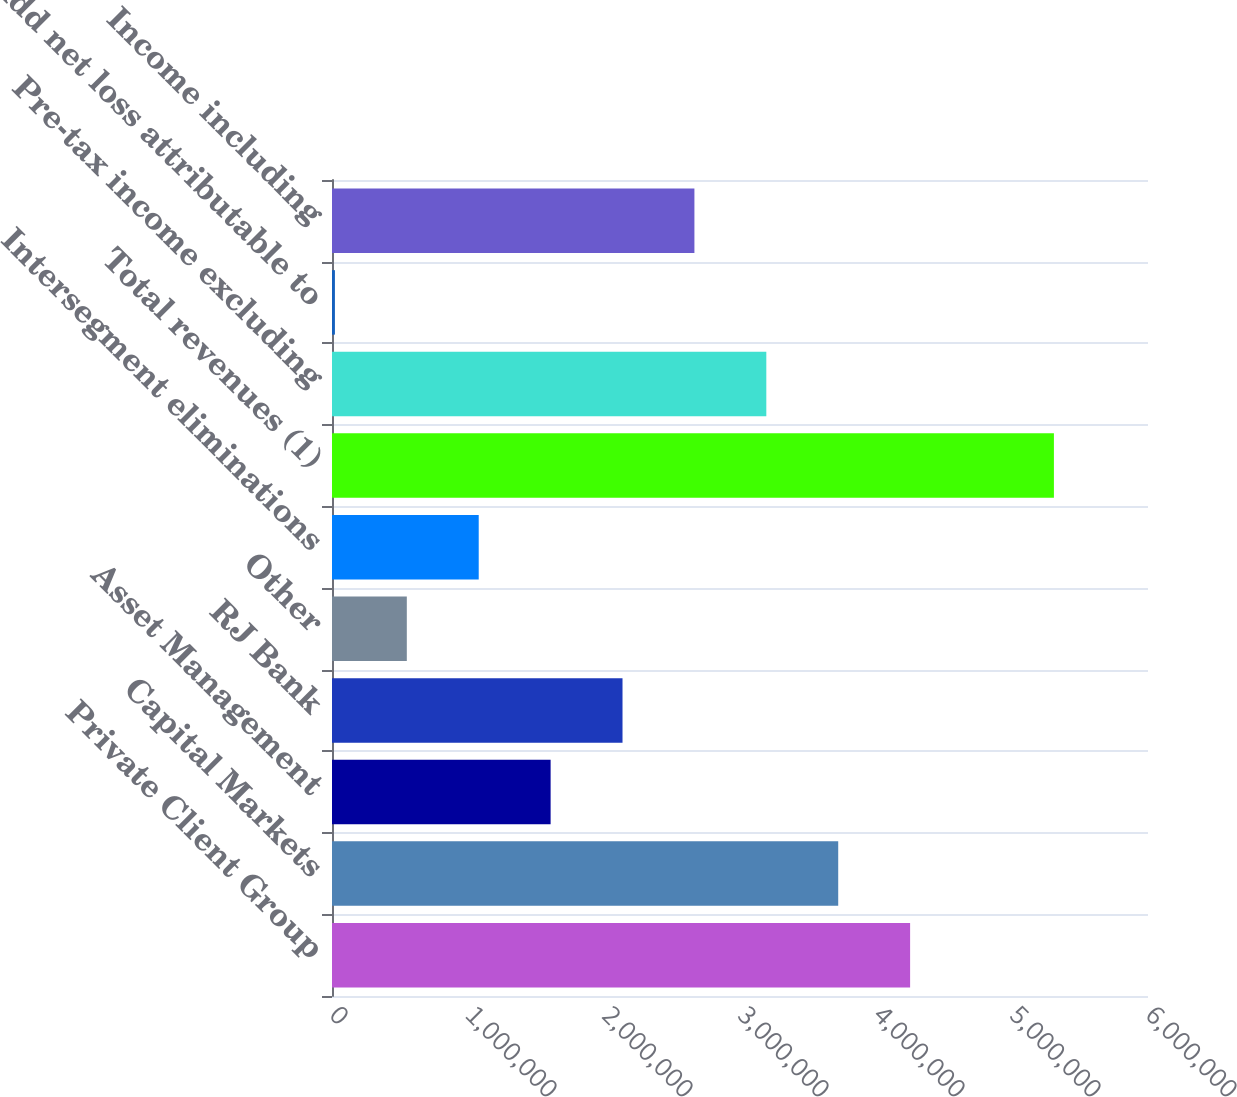<chart> <loc_0><loc_0><loc_500><loc_500><bar_chart><fcel>Private Client Group<fcel>Capital Markets<fcel>Asset Management<fcel>RJ Bank<fcel>Other<fcel>Intersegment eliminations<fcel>Total revenues (1)<fcel>Pre-tax income excluding<fcel>Add net loss attributable to<fcel>Income including<nl><fcel>4.25082e+06<fcel>3.72215e+06<fcel>1.60747e+06<fcel>2.13614e+06<fcel>550132<fcel>1.0788e+06<fcel>5.30816e+06<fcel>3.19348e+06<fcel>21462<fcel>2.66481e+06<nl></chart> 